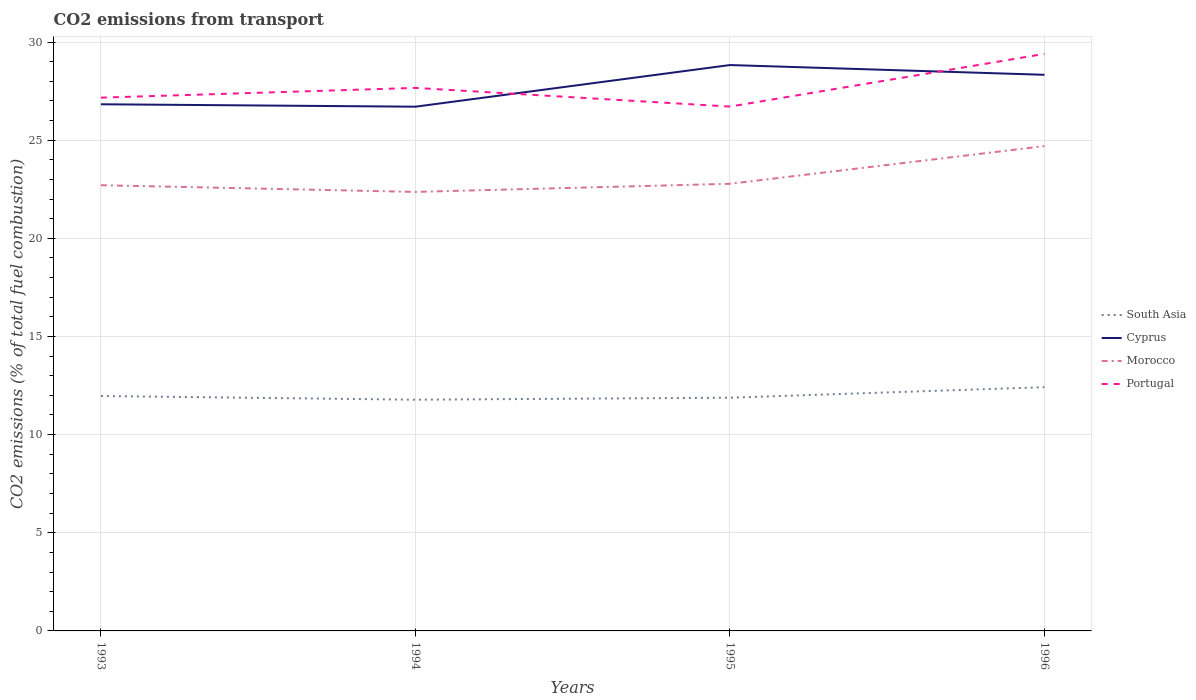Across all years, what is the maximum total CO2 emitted in Cyprus?
Keep it short and to the point. 26.71. What is the total total CO2 emitted in Portugal in the graph?
Provide a succinct answer. -1.73. What is the difference between the highest and the second highest total CO2 emitted in Cyprus?
Offer a very short reply. 2.12. What is the difference between the highest and the lowest total CO2 emitted in Portugal?
Make the answer very short. 1. How many lines are there?
Offer a very short reply. 4. How many years are there in the graph?
Provide a succinct answer. 4. Are the values on the major ticks of Y-axis written in scientific E-notation?
Ensure brevity in your answer.  No. Does the graph contain any zero values?
Keep it short and to the point. No. Where does the legend appear in the graph?
Your answer should be very brief. Center right. How many legend labels are there?
Your answer should be compact. 4. What is the title of the graph?
Keep it short and to the point. CO2 emissions from transport. What is the label or title of the Y-axis?
Offer a very short reply. CO2 emissions (% of total fuel combustion). What is the CO2 emissions (% of total fuel combustion) in South Asia in 1993?
Make the answer very short. 11.97. What is the CO2 emissions (% of total fuel combustion) in Cyprus in 1993?
Offer a very short reply. 26.83. What is the CO2 emissions (% of total fuel combustion) of Morocco in 1993?
Ensure brevity in your answer.  22.71. What is the CO2 emissions (% of total fuel combustion) in Portugal in 1993?
Give a very brief answer. 27.17. What is the CO2 emissions (% of total fuel combustion) of South Asia in 1994?
Provide a short and direct response. 11.78. What is the CO2 emissions (% of total fuel combustion) of Cyprus in 1994?
Provide a succinct answer. 26.71. What is the CO2 emissions (% of total fuel combustion) of Morocco in 1994?
Ensure brevity in your answer.  22.36. What is the CO2 emissions (% of total fuel combustion) of Portugal in 1994?
Your answer should be compact. 27.66. What is the CO2 emissions (% of total fuel combustion) in South Asia in 1995?
Offer a very short reply. 11.88. What is the CO2 emissions (% of total fuel combustion) of Cyprus in 1995?
Keep it short and to the point. 28.83. What is the CO2 emissions (% of total fuel combustion) in Morocco in 1995?
Provide a short and direct response. 22.78. What is the CO2 emissions (% of total fuel combustion) of Portugal in 1995?
Your answer should be compact. 26.71. What is the CO2 emissions (% of total fuel combustion) in South Asia in 1996?
Provide a short and direct response. 12.42. What is the CO2 emissions (% of total fuel combustion) of Cyprus in 1996?
Provide a short and direct response. 28.33. What is the CO2 emissions (% of total fuel combustion) in Morocco in 1996?
Your answer should be very brief. 24.7. What is the CO2 emissions (% of total fuel combustion) of Portugal in 1996?
Offer a very short reply. 29.4. Across all years, what is the maximum CO2 emissions (% of total fuel combustion) in South Asia?
Your answer should be compact. 12.42. Across all years, what is the maximum CO2 emissions (% of total fuel combustion) in Cyprus?
Give a very brief answer. 28.83. Across all years, what is the maximum CO2 emissions (% of total fuel combustion) of Morocco?
Ensure brevity in your answer.  24.7. Across all years, what is the maximum CO2 emissions (% of total fuel combustion) of Portugal?
Make the answer very short. 29.4. Across all years, what is the minimum CO2 emissions (% of total fuel combustion) of South Asia?
Your answer should be compact. 11.78. Across all years, what is the minimum CO2 emissions (% of total fuel combustion) in Cyprus?
Your response must be concise. 26.71. Across all years, what is the minimum CO2 emissions (% of total fuel combustion) of Morocco?
Provide a short and direct response. 22.36. Across all years, what is the minimum CO2 emissions (% of total fuel combustion) of Portugal?
Give a very brief answer. 26.71. What is the total CO2 emissions (% of total fuel combustion) of South Asia in the graph?
Make the answer very short. 48.05. What is the total CO2 emissions (% of total fuel combustion) of Cyprus in the graph?
Your answer should be very brief. 110.69. What is the total CO2 emissions (% of total fuel combustion) of Morocco in the graph?
Your answer should be compact. 92.55. What is the total CO2 emissions (% of total fuel combustion) in Portugal in the graph?
Provide a succinct answer. 110.94. What is the difference between the CO2 emissions (% of total fuel combustion) of South Asia in 1993 and that in 1994?
Provide a short and direct response. 0.19. What is the difference between the CO2 emissions (% of total fuel combustion) of Cyprus in 1993 and that in 1994?
Your response must be concise. 0.12. What is the difference between the CO2 emissions (% of total fuel combustion) in Morocco in 1993 and that in 1994?
Provide a short and direct response. 0.34. What is the difference between the CO2 emissions (% of total fuel combustion) of Portugal in 1993 and that in 1994?
Provide a short and direct response. -0.5. What is the difference between the CO2 emissions (% of total fuel combustion) in South Asia in 1993 and that in 1995?
Your answer should be compact. 0.09. What is the difference between the CO2 emissions (% of total fuel combustion) in Cyprus in 1993 and that in 1995?
Keep it short and to the point. -2. What is the difference between the CO2 emissions (% of total fuel combustion) of Morocco in 1993 and that in 1995?
Make the answer very short. -0.07. What is the difference between the CO2 emissions (% of total fuel combustion) in Portugal in 1993 and that in 1995?
Your answer should be very brief. 0.46. What is the difference between the CO2 emissions (% of total fuel combustion) in South Asia in 1993 and that in 1996?
Your answer should be compact. -0.45. What is the difference between the CO2 emissions (% of total fuel combustion) in Cyprus in 1993 and that in 1996?
Ensure brevity in your answer.  -1.5. What is the difference between the CO2 emissions (% of total fuel combustion) of Morocco in 1993 and that in 1996?
Your response must be concise. -1.99. What is the difference between the CO2 emissions (% of total fuel combustion) in Portugal in 1993 and that in 1996?
Your response must be concise. -2.23. What is the difference between the CO2 emissions (% of total fuel combustion) of South Asia in 1994 and that in 1995?
Offer a very short reply. -0.1. What is the difference between the CO2 emissions (% of total fuel combustion) in Cyprus in 1994 and that in 1995?
Make the answer very short. -2.12. What is the difference between the CO2 emissions (% of total fuel combustion) of Morocco in 1994 and that in 1995?
Offer a terse response. -0.41. What is the difference between the CO2 emissions (% of total fuel combustion) in Portugal in 1994 and that in 1995?
Offer a very short reply. 0.95. What is the difference between the CO2 emissions (% of total fuel combustion) in South Asia in 1994 and that in 1996?
Provide a succinct answer. -0.64. What is the difference between the CO2 emissions (% of total fuel combustion) of Cyprus in 1994 and that in 1996?
Provide a short and direct response. -1.62. What is the difference between the CO2 emissions (% of total fuel combustion) of Morocco in 1994 and that in 1996?
Your answer should be compact. -2.33. What is the difference between the CO2 emissions (% of total fuel combustion) in Portugal in 1994 and that in 1996?
Provide a succinct answer. -1.73. What is the difference between the CO2 emissions (% of total fuel combustion) in South Asia in 1995 and that in 1996?
Your response must be concise. -0.54. What is the difference between the CO2 emissions (% of total fuel combustion) in Cyprus in 1995 and that in 1996?
Your answer should be very brief. 0.5. What is the difference between the CO2 emissions (% of total fuel combustion) of Morocco in 1995 and that in 1996?
Provide a succinct answer. -1.92. What is the difference between the CO2 emissions (% of total fuel combustion) in Portugal in 1995 and that in 1996?
Your answer should be compact. -2.69. What is the difference between the CO2 emissions (% of total fuel combustion) in South Asia in 1993 and the CO2 emissions (% of total fuel combustion) in Cyprus in 1994?
Offer a terse response. -14.74. What is the difference between the CO2 emissions (% of total fuel combustion) in South Asia in 1993 and the CO2 emissions (% of total fuel combustion) in Morocco in 1994?
Ensure brevity in your answer.  -10.4. What is the difference between the CO2 emissions (% of total fuel combustion) of South Asia in 1993 and the CO2 emissions (% of total fuel combustion) of Portugal in 1994?
Offer a very short reply. -15.7. What is the difference between the CO2 emissions (% of total fuel combustion) of Cyprus in 1993 and the CO2 emissions (% of total fuel combustion) of Morocco in 1994?
Keep it short and to the point. 4.46. What is the difference between the CO2 emissions (% of total fuel combustion) in Cyprus in 1993 and the CO2 emissions (% of total fuel combustion) in Portugal in 1994?
Provide a succinct answer. -0.83. What is the difference between the CO2 emissions (% of total fuel combustion) in Morocco in 1993 and the CO2 emissions (% of total fuel combustion) in Portugal in 1994?
Your answer should be very brief. -4.96. What is the difference between the CO2 emissions (% of total fuel combustion) in South Asia in 1993 and the CO2 emissions (% of total fuel combustion) in Cyprus in 1995?
Offer a very short reply. -16.86. What is the difference between the CO2 emissions (% of total fuel combustion) in South Asia in 1993 and the CO2 emissions (% of total fuel combustion) in Morocco in 1995?
Your answer should be very brief. -10.81. What is the difference between the CO2 emissions (% of total fuel combustion) in South Asia in 1993 and the CO2 emissions (% of total fuel combustion) in Portugal in 1995?
Your answer should be compact. -14.74. What is the difference between the CO2 emissions (% of total fuel combustion) in Cyprus in 1993 and the CO2 emissions (% of total fuel combustion) in Morocco in 1995?
Ensure brevity in your answer.  4.05. What is the difference between the CO2 emissions (% of total fuel combustion) of Cyprus in 1993 and the CO2 emissions (% of total fuel combustion) of Portugal in 1995?
Provide a short and direct response. 0.12. What is the difference between the CO2 emissions (% of total fuel combustion) of Morocco in 1993 and the CO2 emissions (% of total fuel combustion) of Portugal in 1995?
Provide a short and direct response. -4.01. What is the difference between the CO2 emissions (% of total fuel combustion) of South Asia in 1993 and the CO2 emissions (% of total fuel combustion) of Cyprus in 1996?
Ensure brevity in your answer.  -16.36. What is the difference between the CO2 emissions (% of total fuel combustion) in South Asia in 1993 and the CO2 emissions (% of total fuel combustion) in Morocco in 1996?
Your answer should be very brief. -12.73. What is the difference between the CO2 emissions (% of total fuel combustion) of South Asia in 1993 and the CO2 emissions (% of total fuel combustion) of Portugal in 1996?
Ensure brevity in your answer.  -17.43. What is the difference between the CO2 emissions (% of total fuel combustion) in Cyprus in 1993 and the CO2 emissions (% of total fuel combustion) in Morocco in 1996?
Give a very brief answer. 2.13. What is the difference between the CO2 emissions (% of total fuel combustion) in Cyprus in 1993 and the CO2 emissions (% of total fuel combustion) in Portugal in 1996?
Offer a terse response. -2.57. What is the difference between the CO2 emissions (% of total fuel combustion) of Morocco in 1993 and the CO2 emissions (% of total fuel combustion) of Portugal in 1996?
Your answer should be compact. -6.69. What is the difference between the CO2 emissions (% of total fuel combustion) of South Asia in 1994 and the CO2 emissions (% of total fuel combustion) of Cyprus in 1995?
Offer a terse response. -17.05. What is the difference between the CO2 emissions (% of total fuel combustion) in South Asia in 1994 and the CO2 emissions (% of total fuel combustion) in Morocco in 1995?
Keep it short and to the point. -11. What is the difference between the CO2 emissions (% of total fuel combustion) of South Asia in 1994 and the CO2 emissions (% of total fuel combustion) of Portugal in 1995?
Provide a succinct answer. -14.93. What is the difference between the CO2 emissions (% of total fuel combustion) of Cyprus in 1994 and the CO2 emissions (% of total fuel combustion) of Morocco in 1995?
Your answer should be compact. 3.93. What is the difference between the CO2 emissions (% of total fuel combustion) of Cyprus in 1994 and the CO2 emissions (% of total fuel combustion) of Portugal in 1995?
Provide a short and direct response. -0.01. What is the difference between the CO2 emissions (% of total fuel combustion) of Morocco in 1994 and the CO2 emissions (% of total fuel combustion) of Portugal in 1995?
Provide a succinct answer. -4.35. What is the difference between the CO2 emissions (% of total fuel combustion) in South Asia in 1994 and the CO2 emissions (% of total fuel combustion) in Cyprus in 1996?
Offer a terse response. -16.55. What is the difference between the CO2 emissions (% of total fuel combustion) in South Asia in 1994 and the CO2 emissions (% of total fuel combustion) in Morocco in 1996?
Keep it short and to the point. -12.92. What is the difference between the CO2 emissions (% of total fuel combustion) of South Asia in 1994 and the CO2 emissions (% of total fuel combustion) of Portugal in 1996?
Give a very brief answer. -17.62. What is the difference between the CO2 emissions (% of total fuel combustion) in Cyprus in 1994 and the CO2 emissions (% of total fuel combustion) in Morocco in 1996?
Make the answer very short. 2.01. What is the difference between the CO2 emissions (% of total fuel combustion) of Cyprus in 1994 and the CO2 emissions (% of total fuel combustion) of Portugal in 1996?
Ensure brevity in your answer.  -2.69. What is the difference between the CO2 emissions (% of total fuel combustion) of Morocco in 1994 and the CO2 emissions (% of total fuel combustion) of Portugal in 1996?
Provide a succinct answer. -7.03. What is the difference between the CO2 emissions (% of total fuel combustion) in South Asia in 1995 and the CO2 emissions (% of total fuel combustion) in Cyprus in 1996?
Provide a short and direct response. -16.45. What is the difference between the CO2 emissions (% of total fuel combustion) in South Asia in 1995 and the CO2 emissions (% of total fuel combustion) in Morocco in 1996?
Provide a short and direct response. -12.82. What is the difference between the CO2 emissions (% of total fuel combustion) of South Asia in 1995 and the CO2 emissions (% of total fuel combustion) of Portugal in 1996?
Provide a succinct answer. -17.52. What is the difference between the CO2 emissions (% of total fuel combustion) in Cyprus in 1995 and the CO2 emissions (% of total fuel combustion) in Morocco in 1996?
Give a very brief answer. 4.13. What is the difference between the CO2 emissions (% of total fuel combustion) of Cyprus in 1995 and the CO2 emissions (% of total fuel combustion) of Portugal in 1996?
Provide a short and direct response. -0.57. What is the difference between the CO2 emissions (% of total fuel combustion) in Morocco in 1995 and the CO2 emissions (% of total fuel combustion) in Portugal in 1996?
Keep it short and to the point. -6.62. What is the average CO2 emissions (% of total fuel combustion) in South Asia per year?
Your answer should be very brief. 12.01. What is the average CO2 emissions (% of total fuel combustion) in Cyprus per year?
Provide a short and direct response. 27.67. What is the average CO2 emissions (% of total fuel combustion) in Morocco per year?
Keep it short and to the point. 23.14. What is the average CO2 emissions (% of total fuel combustion) in Portugal per year?
Keep it short and to the point. 27.73. In the year 1993, what is the difference between the CO2 emissions (% of total fuel combustion) in South Asia and CO2 emissions (% of total fuel combustion) in Cyprus?
Offer a very short reply. -14.86. In the year 1993, what is the difference between the CO2 emissions (% of total fuel combustion) in South Asia and CO2 emissions (% of total fuel combustion) in Morocco?
Your answer should be very brief. -10.74. In the year 1993, what is the difference between the CO2 emissions (% of total fuel combustion) of South Asia and CO2 emissions (% of total fuel combustion) of Portugal?
Give a very brief answer. -15.2. In the year 1993, what is the difference between the CO2 emissions (% of total fuel combustion) in Cyprus and CO2 emissions (% of total fuel combustion) in Morocco?
Keep it short and to the point. 4.12. In the year 1993, what is the difference between the CO2 emissions (% of total fuel combustion) of Cyprus and CO2 emissions (% of total fuel combustion) of Portugal?
Your answer should be compact. -0.34. In the year 1993, what is the difference between the CO2 emissions (% of total fuel combustion) in Morocco and CO2 emissions (% of total fuel combustion) in Portugal?
Offer a very short reply. -4.46. In the year 1994, what is the difference between the CO2 emissions (% of total fuel combustion) in South Asia and CO2 emissions (% of total fuel combustion) in Cyprus?
Provide a succinct answer. -14.93. In the year 1994, what is the difference between the CO2 emissions (% of total fuel combustion) in South Asia and CO2 emissions (% of total fuel combustion) in Morocco?
Your answer should be very brief. -10.59. In the year 1994, what is the difference between the CO2 emissions (% of total fuel combustion) in South Asia and CO2 emissions (% of total fuel combustion) in Portugal?
Give a very brief answer. -15.88. In the year 1994, what is the difference between the CO2 emissions (% of total fuel combustion) of Cyprus and CO2 emissions (% of total fuel combustion) of Morocco?
Make the answer very short. 4.34. In the year 1994, what is the difference between the CO2 emissions (% of total fuel combustion) of Cyprus and CO2 emissions (% of total fuel combustion) of Portugal?
Your response must be concise. -0.96. In the year 1994, what is the difference between the CO2 emissions (% of total fuel combustion) of Morocco and CO2 emissions (% of total fuel combustion) of Portugal?
Keep it short and to the point. -5.3. In the year 1995, what is the difference between the CO2 emissions (% of total fuel combustion) of South Asia and CO2 emissions (% of total fuel combustion) of Cyprus?
Offer a terse response. -16.95. In the year 1995, what is the difference between the CO2 emissions (% of total fuel combustion) in South Asia and CO2 emissions (% of total fuel combustion) in Morocco?
Make the answer very short. -10.9. In the year 1995, what is the difference between the CO2 emissions (% of total fuel combustion) in South Asia and CO2 emissions (% of total fuel combustion) in Portugal?
Offer a terse response. -14.83. In the year 1995, what is the difference between the CO2 emissions (% of total fuel combustion) of Cyprus and CO2 emissions (% of total fuel combustion) of Morocco?
Offer a very short reply. 6.05. In the year 1995, what is the difference between the CO2 emissions (% of total fuel combustion) in Cyprus and CO2 emissions (% of total fuel combustion) in Portugal?
Make the answer very short. 2.12. In the year 1995, what is the difference between the CO2 emissions (% of total fuel combustion) of Morocco and CO2 emissions (% of total fuel combustion) of Portugal?
Ensure brevity in your answer.  -3.93. In the year 1996, what is the difference between the CO2 emissions (% of total fuel combustion) of South Asia and CO2 emissions (% of total fuel combustion) of Cyprus?
Ensure brevity in your answer.  -15.91. In the year 1996, what is the difference between the CO2 emissions (% of total fuel combustion) of South Asia and CO2 emissions (% of total fuel combustion) of Morocco?
Ensure brevity in your answer.  -12.28. In the year 1996, what is the difference between the CO2 emissions (% of total fuel combustion) of South Asia and CO2 emissions (% of total fuel combustion) of Portugal?
Give a very brief answer. -16.98. In the year 1996, what is the difference between the CO2 emissions (% of total fuel combustion) in Cyprus and CO2 emissions (% of total fuel combustion) in Morocco?
Make the answer very short. 3.63. In the year 1996, what is the difference between the CO2 emissions (% of total fuel combustion) of Cyprus and CO2 emissions (% of total fuel combustion) of Portugal?
Your answer should be compact. -1.07. In the year 1996, what is the difference between the CO2 emissions (% of total fuel combustion) in Morocco and CO2 emissions (% of total fuel combustion) in Portugal?
Ensure brevity in your answer.  -4.7. What is the ratio of the CO2 emissions (% of total fuel combustion) in South Asia in 1993 to that in 1994?
Your answer should be compact. 1.02. What is the ratio of the CO2 emissions (% of total fuel combustion) in Morocco in 1993 to that in 1994?
Provide a succinct answer. 1.02. What is the ratio of the CO2 emissions (% of total fuel combustion) in Portugal in 1993 to that in 1994?
Keep it short and to the point. 0.98. What is the ratio of the CO2 emissions (% of total fuel combustion) of South Asia in 1993 to that in 1995?
Provide a succinct answer. 1.01. What is the ratio of the CO2 emissions (% of total fuel combustion) of Cyprus in 1993 to that in 1995?
Your response must be concise. 0.93. What is the ratio of the CO2 emissions (% of total fuel combustion) in South Asia in 1993 to that in 1996?
Provide a short and direct response. 0.96. What is the ratio of the CO2 emissions (% of total fuel combustion) in Cyprus in 1993 to that in 1996?
Offer a terse response. 0.95. What is the ratio of the CO2 emissions (% of total fuel combustion) of Morocco in 1993 to that in 1996?
Provide a short and direct response. 0.92. What is the ratio of the CO2 emissions (% of total fuel combustion) of Portugal in 1993 to that in 1996?
Make the answer very short. 0.92. What is the ratio of the CO2 emissions (% of total fuel combustion) in South Asia in 1994 to that in 1995?
Provide a short and direct response. 0.99. What is the ratio of the CO2 emissions (% of total fuel combustion) of Cyprus in 1994 to that in 1995?
Your response must be concise. 0.93. What is the ratio of the CO2 emissions (% of total fuel combustion) of Morocco in 1994 to that in 1995?
Provide a short and direct response. 0.98. What is the ratio of the CO2 emissions (% of total fuel combustion) of Portugal in 1994 to that in 1995?
Provide a succinct answer. 1.04. What is the ratio of the CO2 emissions (% of total fuel combustion) in South Asia in 1994 to that in 1996?
Keep it short and to the point. 0.95. What is the ratio of the CO2 emissions (% of total fuel combustion) in Cyprus in 1994 to that in 1996?
Provide a succinct answer. 0.94. What is the ratio of the CO2 emissions (% of total fuel combustion) in Morocco in 1994 to that in 1996?
Provide a succinct answer. 0.91. What is the ratio of the CO2 emissions (% of total fuel combustion) in Portugal in 1994 to that in 1996?
Offer a very short reply. 0.94. What is the ratio of the CO2 emissions (% of total fuel combustion) in South Asia in 1995 to that in 1996?
Provide a short and direct response. 0.96. What is the ratio of the CO2 emissions (% of total fuel combustion) of Cyprus in 1995 to that in 1996?
Offer a very short reply. 1.02. What is the ratio of the CO2 emissions (% of total fuel combustion) of Morocco in 1995 to that in 1996?
Provide a succinct answer. 0.92. What is the ratio of the CO2 emissions (% of total fuel combustion) of Portugal in 1995 to that in 1996?
Give a very brief answer. 0.91. What is the difference between the highest and the second highest CO2 emissions (% of total fuel combustion) in South Asia?
Your answer should be very brief. 0.45. What is the difference between the highest and the second highest CO2 emissions (% of total fuel combustion) of Cyprus?
Provide a succinct answer. 0.5. What is the difference between the highest and the second highest CO2 emissions (% of total fuel combustion) in Morocco?
Your answer should be very brief. 1.92. What is the difference between the highest and the second highest CO2 emissions (% of total fuel combustion) of Portugal?
Your answer should be very brief. 1.73. What is the difference between the highest and the lowest CO2 emissions (% of total fuel combustion) of South Asia?
Provide a short and direct response. 0.64. What is the difference between the highest and the lowest CO2 emissions (% of total fuel combustion) in Cyprus?
Provide a succinct answer. 2.12. What is the difference between the highest and the lowest CO2 emissions (% of total fuel combustion) in Morocco?
Offer a very short reply. 2.33. What is the difference between the highest and the lowest CO2 emissions (% of total fuel combustion) of Portugal?
Provide a succinct answer. 2.69. 